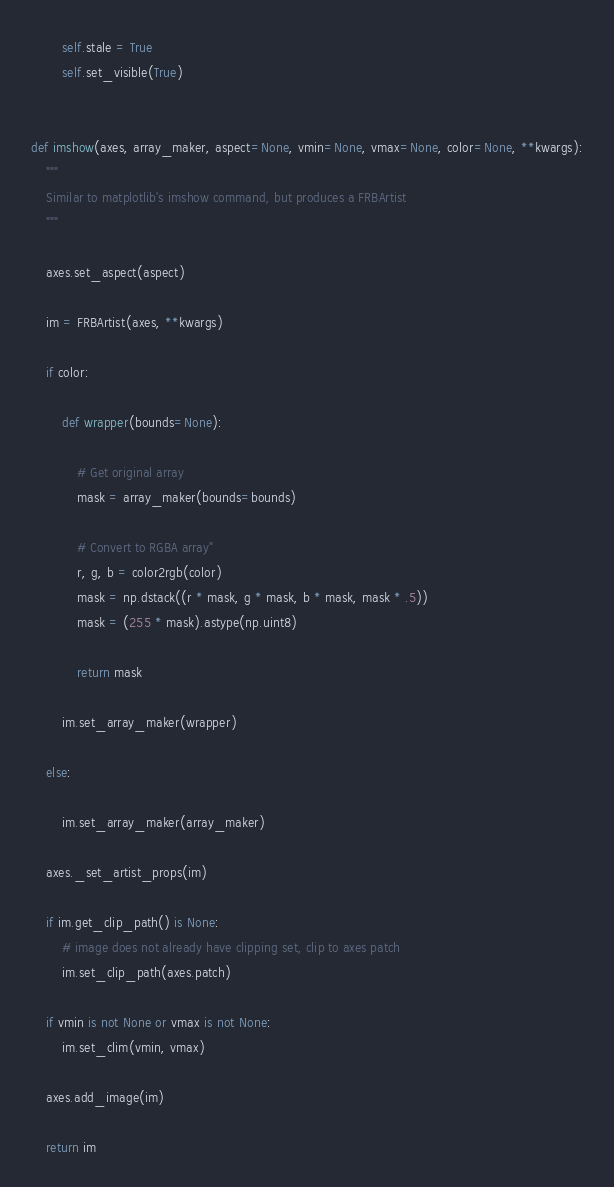Convert code to text. <code><loc_0><loc_0><loc_500><loc_500><_Python_>        self.stale = True
        self.set_visible(True)


def imshow(axes, array_maker, aspect=None, vmin=None, vmax=None, color=None, **kwargs):
    """
    Similar to matplotlib's imshow command, but produces a FRBArtist
    """

    axes.set_aspect(aspect)

    im = FRBArtist(axes, **kwargs)

    if color:

        def wrapper(bounds=None):

            # Get original array
            mask = array_maker(bounds=bounds)

            # Convert to RGBA array"
            r, g, b = color2rgb(color)
            mask = np.dstack((r * mask, g * mask, b * mask, mask * .5))
            mask = (255 * mask).astype(np.uint8)

            return mask

        im.set_array_maker(wrapper)

    else:

        im.set_array_maker(array_maker)

    axes._set_artist_props(im)

    if im.get_clip_path() is None:
        # image does not already have clipping set, clip to axes patch
        im.set_clip_path(axes.patch)

    if vmin is not None or vmax is not None:
        im.set_clim(vmin, vmax)

    axes.add_image(im)

    return im
</code> 